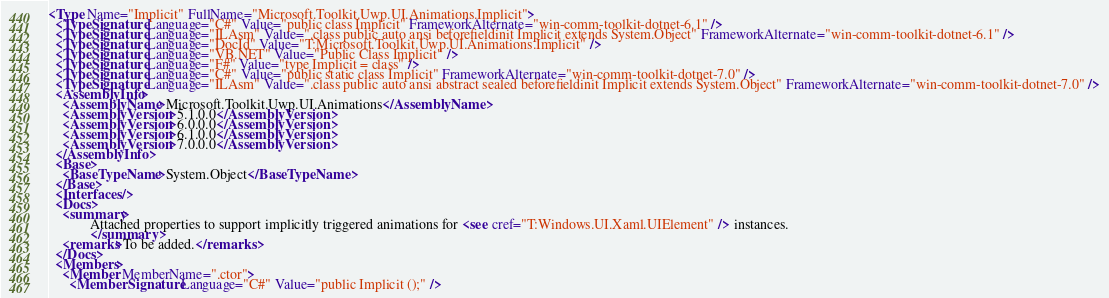<code> <loc_0><loc_0><loc_500><loc_500><_XML_><Type Name="Implicit" FullName="Microsoft.Toolkit.Uwp.UI.Animations.Implicit">
  <TypeSignature Language="C#" Value="public class Implicit" FrameworkAlternate="win-comm-toolkit-dotnet-6.1" />
  <TypeSignature Language="ILAsm" Value=".class public auto ansi beforefieldinit Implicit extends System.Object" FrameworkAlternate="win-comm-toolkit-dotnet-6.1" />
  <TypeSignature Language="DocId" Value="T:Microsoft.Toolkit.Uwp.UI.Animations.Implicit" />
  <TypeSignature Language="VB.NET" Value="Public Class Implicit" />
  <TypeSignature Language="F#" Value="type Implicit = class" />
  <TypeSignature Language="C#" Value="public static class Implicit" FrameworkAlternate="win-comm-toolkit-dotnet-7.0" />
  <TypeSignature Language="ILAsm" Value=".class public auto ansi abstract sealed beforefieldinit Implicit extends System.Object" FrameworkAlternate="win-comm-toolkit-dotnet-7.0" />
  <AssemblyInfo>
    <AssemblyName>Microsoft.Toolkit.Uwp.UI.Animations</AssemblyName>
    <AssemblyVersion>5.1.0.0</AssemblyVersion>
    <AssemblyVersion>6.0.0.0</AssemblyVersion>
    <AssemblyVersion>6.1.0.0</AssemblyVersion>
    <AssemblyVersion>7.0.0.0</AssemblyVersion>
  </AssemblyInfo>
  <Base>
    <BaseTypeName>System.Object</BaseTypeName>
  </Base>
  <Interfaces />
  <Docs>
    <summary>
            Attached properties to support implicitly triggered animations for <see cref="T:Windows.UI.Xaml.UIElement" /> instances.
            </summary>
    <remarks>To be added.</remarks>
  </Docs>
  <Members>
    <Member MemberName=".ctor">
      <MemberSignature Language="C#" Value="public Implicit ();" /></code> 